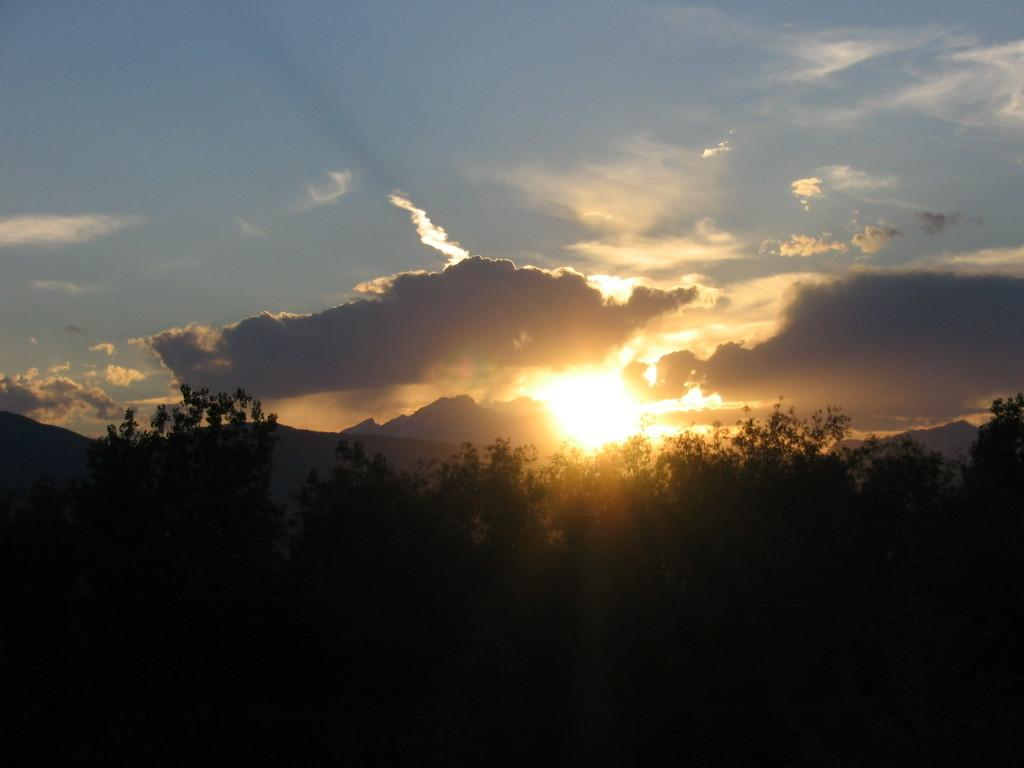What type of living organisms can be seen in the image? Plants can be seen in the image. What can be seen in the background of the image? Hills are visible in the background of the image. What is visible in the sky in the image? Clouds and sunshine are visible in the sky in the image. What type of oil is being used to water the plants in the image? There is no oil present in the image, and the plants are not being watered. 